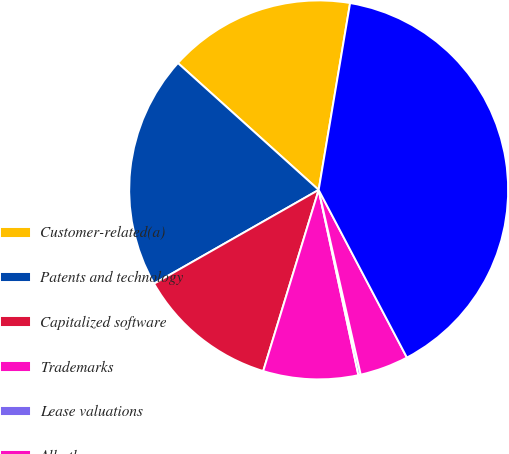Convert chart. <chart><loc_0><loc_0><loc_500><loc_500><pie_chart><fcel>Customer-related(a)<fcel>Patents and technology<fcel>Capitalized software<fcel>Trademarks<fcel>Lease valuations<fcel>All other<fcel>Total<nl><fcel>15.98%<fcel>19.92%<fcel>12.03%<fcel>8.09%<fcel>0.2%<fcel>4.15%<fcel>39.64%<nl></chart> 